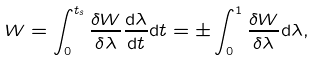<formula> <loc_0><loc_0><loc_500><loc_500>W = \int _ { 0 } ^ { t _ { s } } \frac { \delta W } { \delta \lambda } \frac { \mathrm d \lambda } { \mathrm d t } \mathrm d t = \pm \int _ { 0 } ^ { 1 } \frac { \delta W } { \delta \lambda } \mathrm d \lambda ,</formula> 